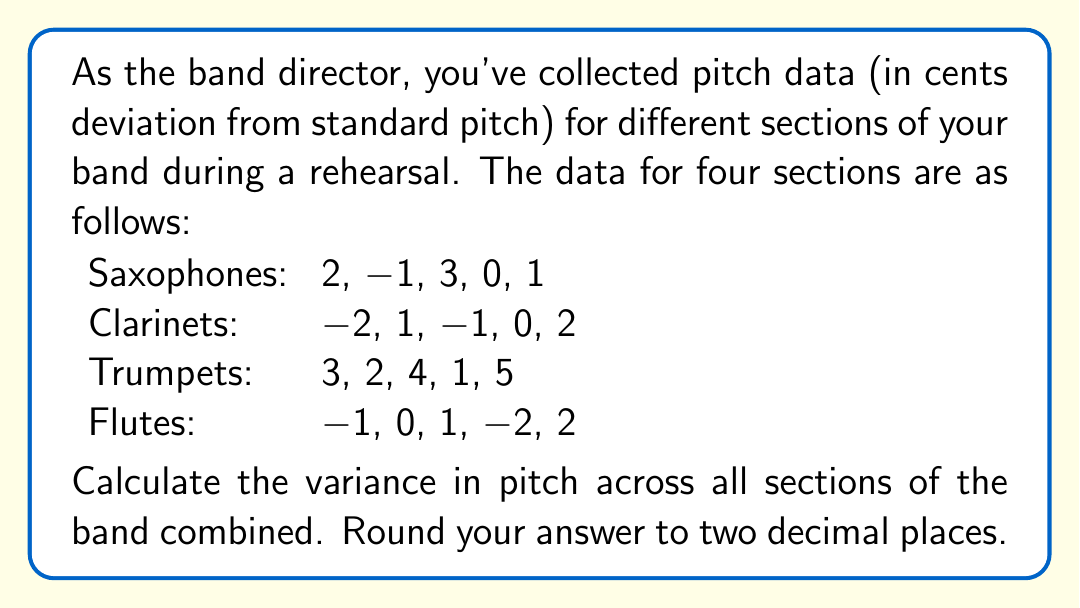Give your solution to this math problem. To calculate the variance across all sections, we'll treat this as one combined dataset and follow these steps:

1) First, calculate the mean of all the data points:

$$\bar{x} = \frac{\sum_{i=1}^{n} x_i}{n}$$

Where $n$ is the total number of data points (20 in this case).

$$\bar{x} = \frac{2 + (-1) + 3 + 0 + 1 + (-2) + 1 + (-1) + 0 + 2 + 3 + 2 + 4 + 1 + 5 + (-1) + 0 + 1 + (-2) + 2}{20} = 1$$

2) Now, calculate the squared differences from the mean:

$$(2-1)^2 = 1, (-1-1)^2 = 4, (3-1)^2 = 4, (0-1)^2 = 1, (1-1)^2 = 0,$$
$$(-2-1)^2 = 9, (1-1)^2 = 0, (-1-1)^2 = 4, (0-1)^2 = 1, (2-1)^2 = 1,$$
$$(3-1)^2 = 4, (2-1)^2 = 1, (4-1)^2 = 9, (1-1)^2 = 0, (5-1)^2 = 16,$$
$$(-1-1)^2 = 4, (0-1)^2 = 1, (1-1)^2 = 0, (-2-1)^2 = 9, (2-1)^2 = 1$$

3) Sum these squared differences:

$$\sum_{i=1}^{n} (x_i - \bar{x})^2 = 70$$

4) Divide by $(n-1)$ to get the variance:

$$s^2 = \frac{\sum_{i=1}^{n} (x_i - \bar{x})^2}{n-1} = \frac{70}{19} \approx 3.6842$$

5) Round to two decimal places: 3.68
Answer: 3.68 